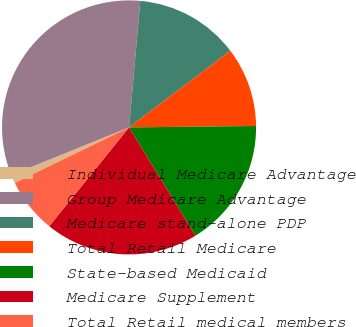Convert chart. <chart><loc_0><loc_0><loc_500><loc_500><pie_chart><fcel>Individual Medicare Advantage<fcel>Group Medicare Advantage<fcel>Medicare stand-alone PDP<fcel>Total Retail Medicare<fcel>State-based Medicaid<fcel>Medicare Supplement<fcel>Total Retail medical members<nl><fcel>1.08%<fcel>32.53%<fcel>13.28%<fcel>10.13%<fcel>16.42%<fcel>19.57%<fcel>6.99%<nl></chart> 